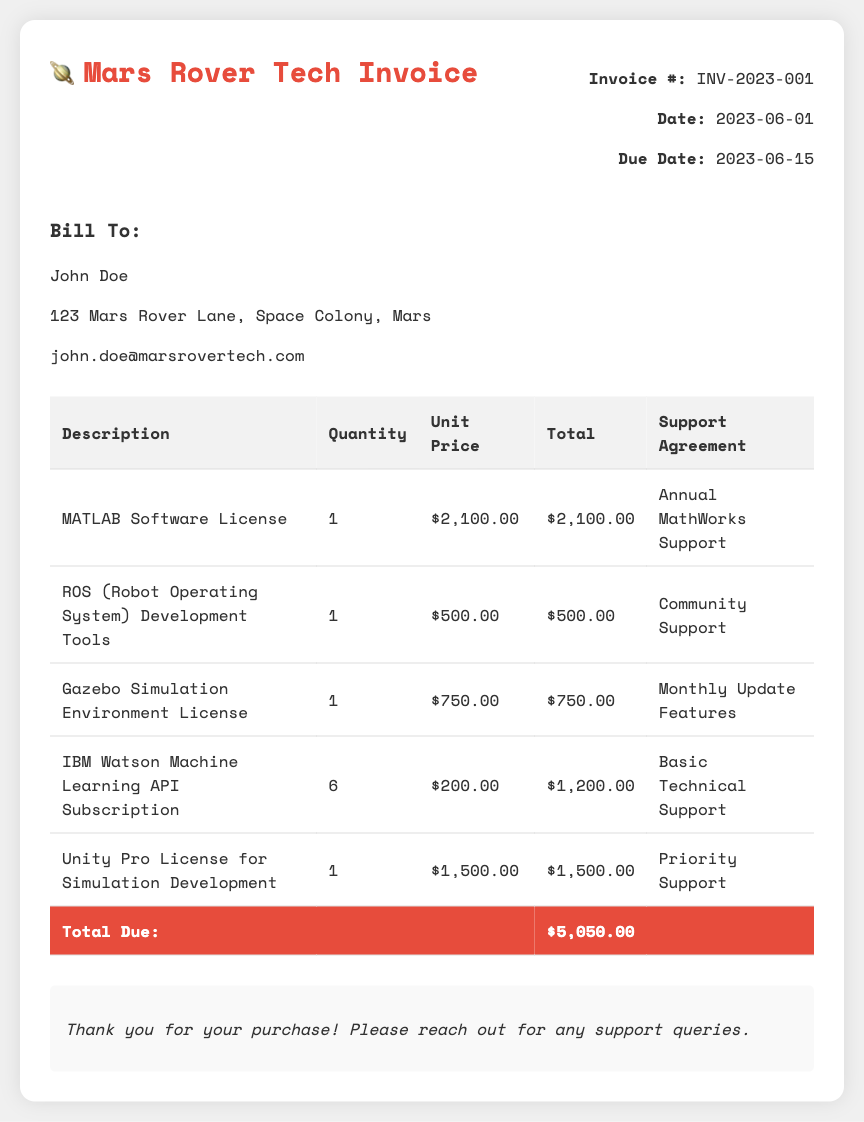What is the invoice number? The invoice number is specified in the document for reference.
Answer: INV-2023-001 What is the total due amount? The total due amount is provided at the end of the itemized list of costs.
Answer: $5,050.00 What is the due date for the invoice? The due date is crucial for payment purposes and is indicated in the document.
Answer: 2023-06-15 How many IBM Watson Machine Learning API subscriptions were purchased? The number of subscriptions purchased is listed under the item details.
Answer: 6 What type of support agreement comes with the MATLAB Software License? The support agreement is specified for each software in the table.
Answer: Annual MathWorks Support What is the unit price of the Gazebo Simulation Environment License? The unit price is listed beside the description in the invoice table.
Answer: $750.00 Which item has the highest unit price? The highest unit price can be determined by comparing the unit prices listed in the table.
Answer: MATLAB Software License Which company is the invoice addressed to? The recipient's information includes the name and address provided in the document.
Answer: John Doe What is the payment reminder mentioned in the document? The document includes a note after the total due amount as a reminder for payment follow-up.
Answer: Thank you for your purchase! Please reach out for any support queries 